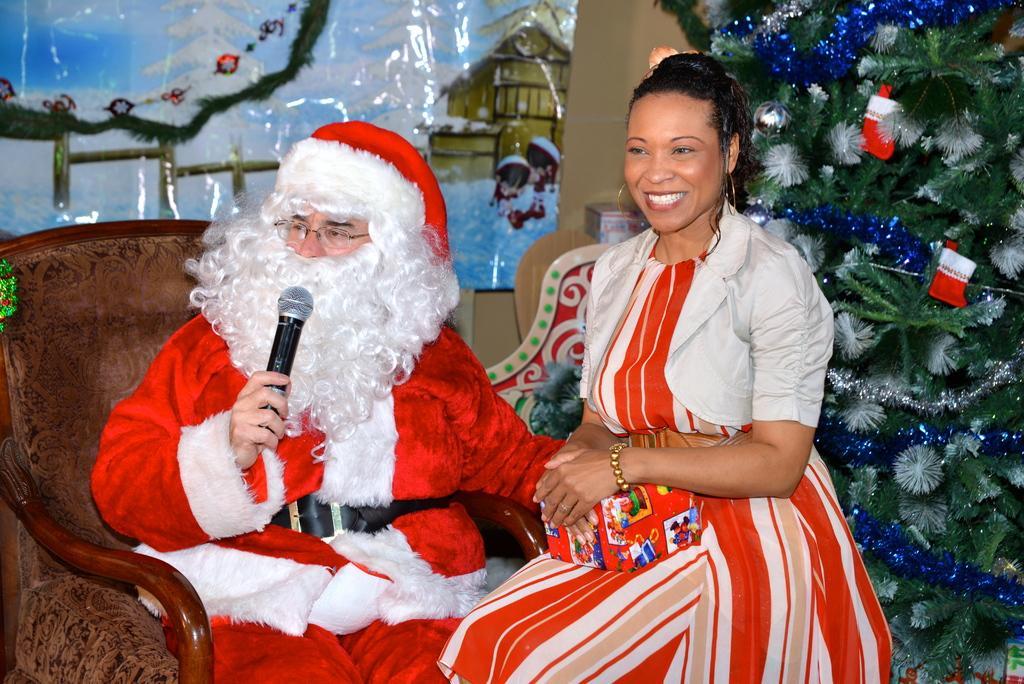Could you give a brief overview of what you see in this image? In the image there is a person wearing santa costume, he is sitting on a chair and talking something. Beside him there is a woman sitting and holding a gift and behind the woman there is a christmas tree and in the background there is a poster attached to the wall. 